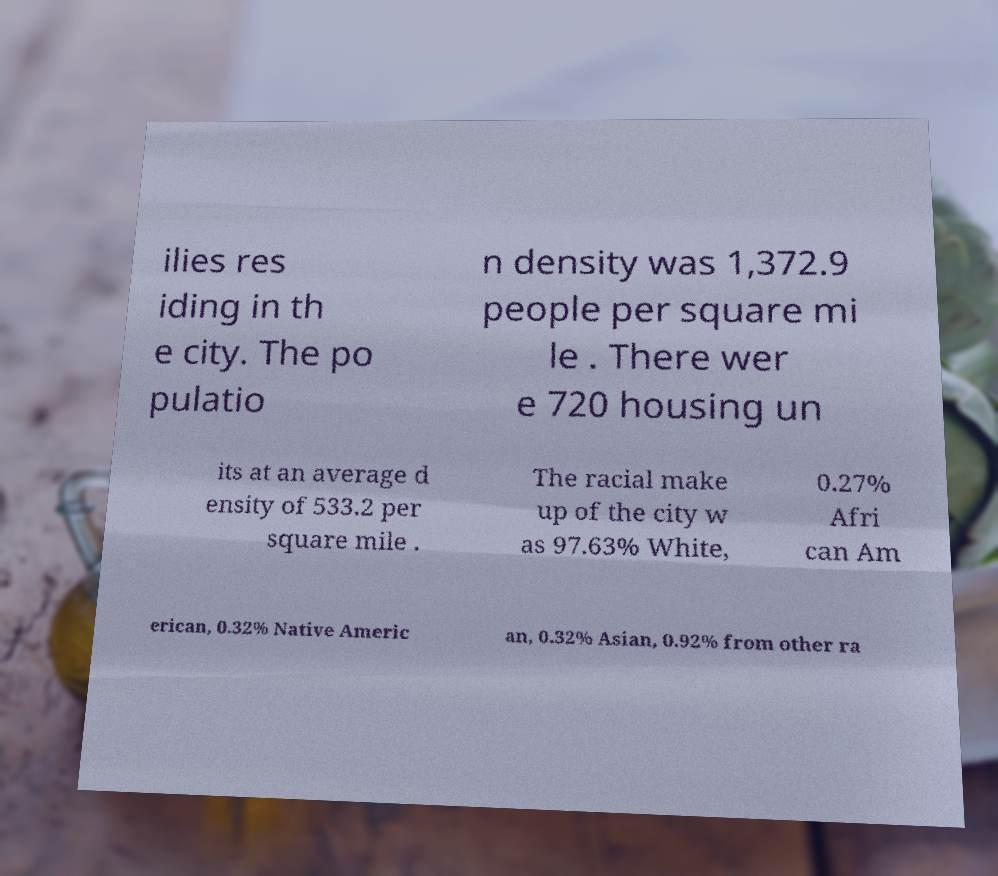Could you assist in decoding the text presented in this image and type it out clearly? ilies res iding in th e city. The po pulatio n density was 1,372.9 people per square mi le . There wer e 720 housing un its at an average d ensity of 533.2 per square mile . The racial make up of the city w as 97.63% White, 0.27% Afri can Am erican, 0.32% Native Americ an, 0.32% Asian, 0.92% from other ra 